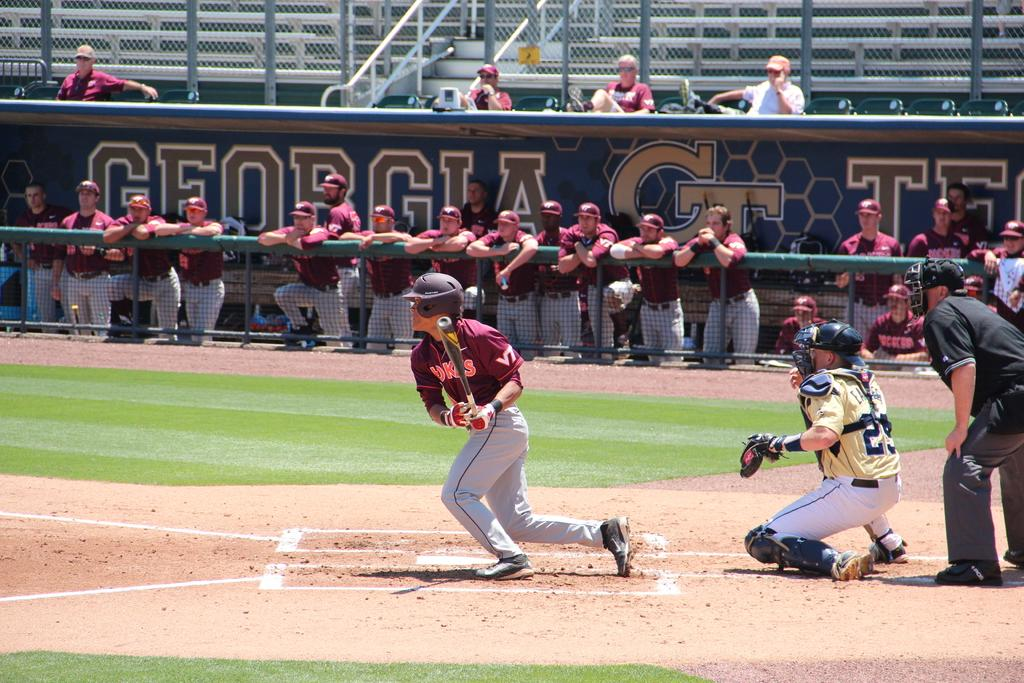<image>
Summarize the visual content of the image. Players are in a dugout, with the name Georgia Tech written on it. 